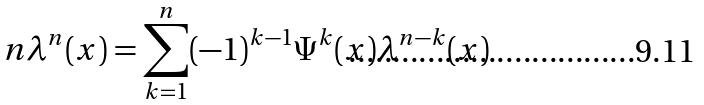Convert formula to latex. <formula><loc_0><loc_0><loc_500><loc_500>n \lambda ^ { n } ( x ) = \sum _ { k = 1 } ^ { n } ( - 1 ) ^ { k - 1 } \Psi ^ { k } ( x ) \lambda ^ { n - k } ( x )</formula> 